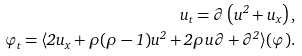Convert formula to latex. <formula><loc_0><loc_0><loc_500><loc_500>u _ { t } = \partial \left ( u ^ { 2 } + u _ { x } \right ) , \\ \varphi _ { t } = \langle 2 u _ { x } + \rho ( \rho - 1 ) u ^ { 2 } + 2 \rho u \partial + \partial ^ { 2 } \rangle ( \varphi ) .</formula> 